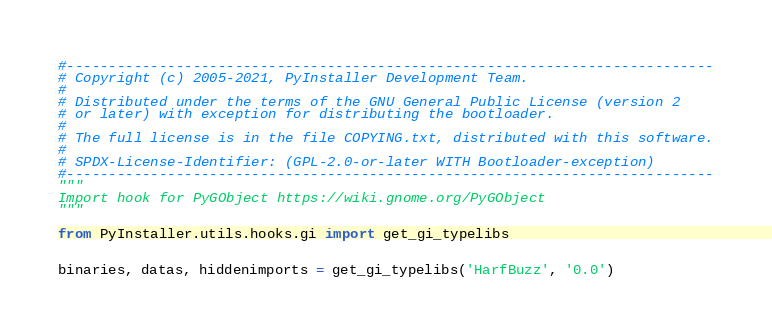<code> <loc_0><loc_0><loc_500><loc_500><_Python_>#-----------------------------------------------------------------------------
# Copyright (c) 2005-2021, PyInstaller Development Team.
#
# Distributed under the terms of the GNU General Public License (version 2
# or later) with exception for distributing the bootloader.
#
# The full license is in the file COPYING.txt, distributed with this software.
#
# SPDX-License-Identifier: (GPL-2.0-or-later WITH Bootloader-exception)
#-----------------------------------------------------------------------------
"""
Import hook for PyGObject https://wiki.gnome.org/PyGObject
"""

from PyInstaller.utils.hooks.gi import get_gi_typelibs


binaries, datas, hiddenimports = get_gi_typelibs('HarfBuzz', '0.0')
</code> 